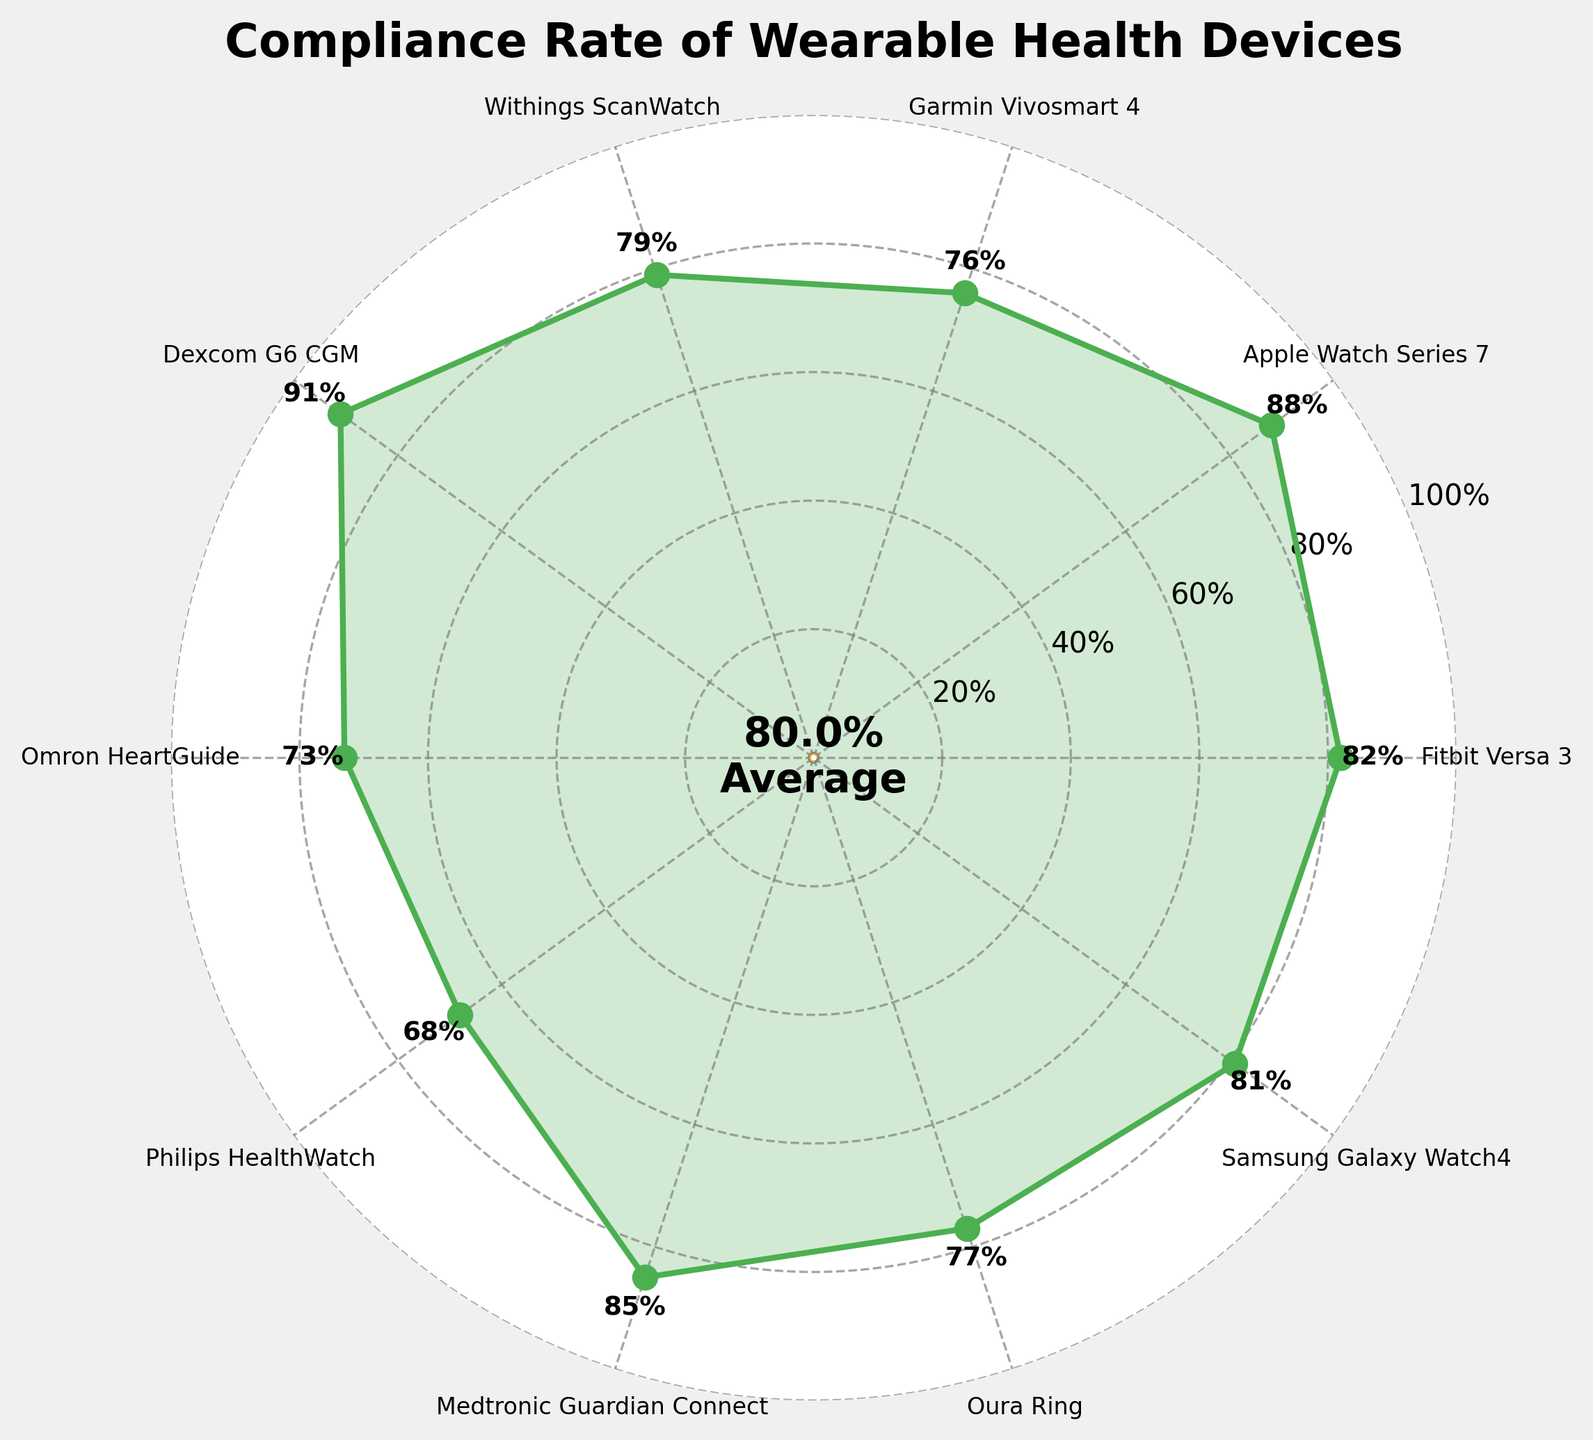Which device has the highest compliance rate? The device with the highest compliance rate will be at the maximum point on the chart. By examining the figure, Dexcom G6 CGM has the highest compliance rate.
Answer: Dexcom G6 CGM What is the average compliance rate of all devices? The average compliance rate is indicated by the gauge in the center of the chart. Based on the figure, the average compliance rate is shown as 82.0%.
Answer: 82.0% Which devices have a compliance rate below 75%? Devices below 75% are located in the lower part of the chart. By examining the figure, Omron HeartGuide and Philips HealthWatch have compliance rates below 75%.
Answer: Omron HeartGuide, Philips HealthWatch How does the compliance rate of the Apple Watch Series 7 compare to that of the Fitbit Versa 3? To compare the two devices, we need to check their positions on the chart for compliance rates. Apple Watch Series 7 has a compliance rate of 88%, while Fitbit Versa 3 has a compliance rate of 82%.
Answer: Apple Watch Series 7 is higher What is the compliance rate range observed among the devices? To determine the range, find the difference between the highest and lowest compliance rates on the chart. Dexcom G6 CGM is 91%, and Philips HealthWatch is 68%; thus, the range is 91% - 68%.
Answer: 23% Which two devices have compliance rates closest to the average compliance rate? First, identify the average compliance rate, which is 82.0%. Then find the devices close to this value. Fitbit Versa 3 (82%) and Samsung Galaxy Watch4 (81%) are closest to the average.
Answer: Fitbit Versa 3, Samsung Galaxy Watch4 Is the compliance rate of the Medtronic Guardian Connect above or below the average compliance rate? Checking the chart, Medtronic Guardian Connect has an 85% compliance rate, while the average is 82.0%.
Answer: Above How many devices have a compliance rate above 80%? Count the devices on the chart with compliance rates above 80%. Fitbit Versa 3, Apple Watch Series 7, Dexcom G6 CGM, Medtronic Guardian Connect, and Samsung Galaxy Watch4 (5 devices) meet this criterion.
Answer: 5 What is the compliance rate of the Garmin Vivosmart 4? Locate Garmin Vivosmart 4 on the chart and note the associated compliance rate. The compliance rate is 76%.
Answer: 76% Which of the devices has the lowest compliance rate, and what is that rate? Identify the device with the lowest position on the chart, which is Philips HealthWatch with a compliance rate of 68%.
Answer: Philips HealthWatch, 68% 